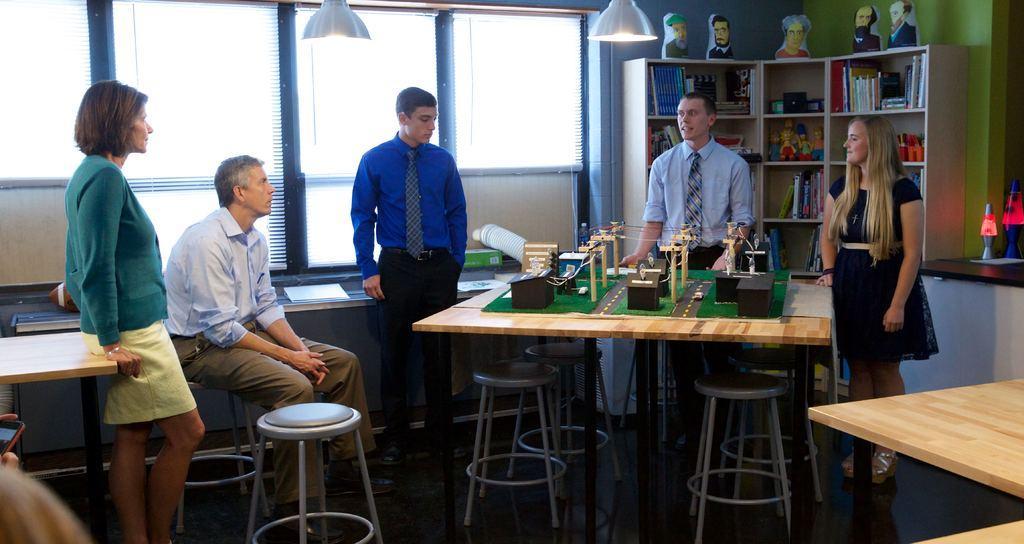How would you summarize this image in a sentence or two? This rack is filled with books and toys. Above this rock there are sculptures. On top there are lights. These persons are standing. On this table there is a plan for construction. Under the table there are chairs. This person is sitting on a chair. This is window. 